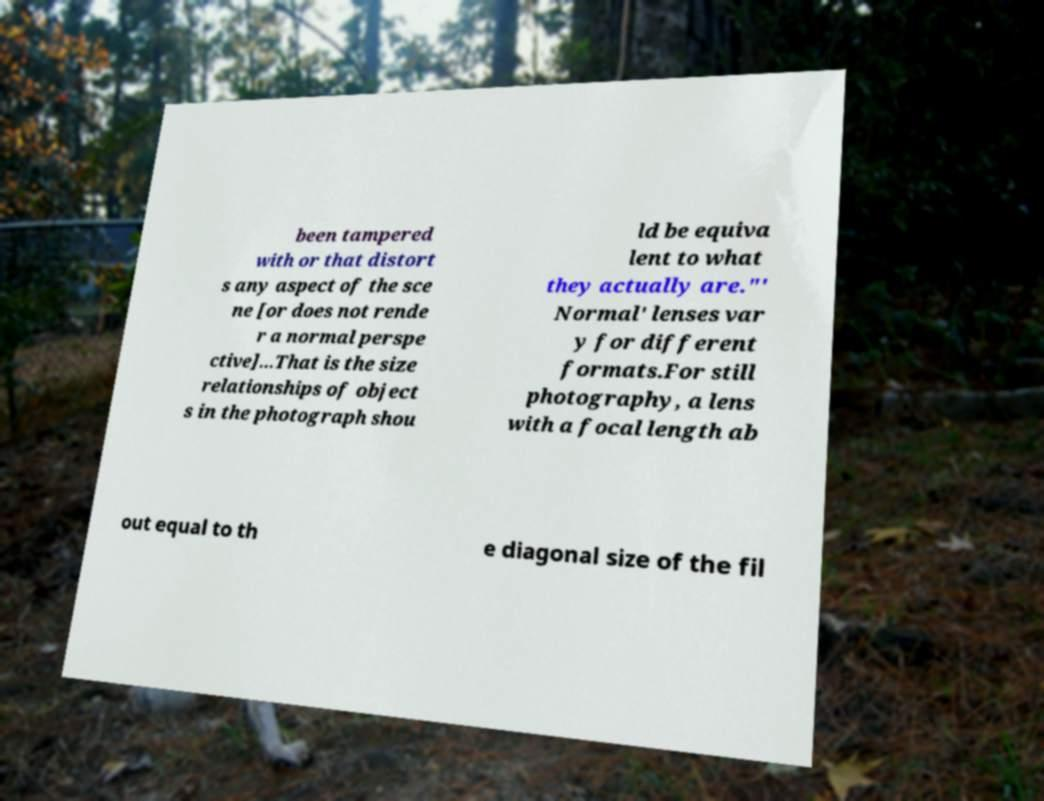Please read and relay the text visible in this image. What does it say? been tampered with or that distort s any aspect of the sce ne [or does not rende r a normal perspe ctive]...That is the size relationships of object s in the photograph shou ld be equiva lent to what they actually are."' Normal' lenses var y for different formats.For still photography, a lens with a focal length ab out equal to th e diagonal size of the fil 